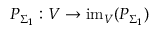<formula> <loc_0><loc_0><loc_500><loc_500>P _ { \Sigma _ { 1 } } \colon V \to i m _ { V } ( P _ { \Sigma _ { 1 } } )</formula> 